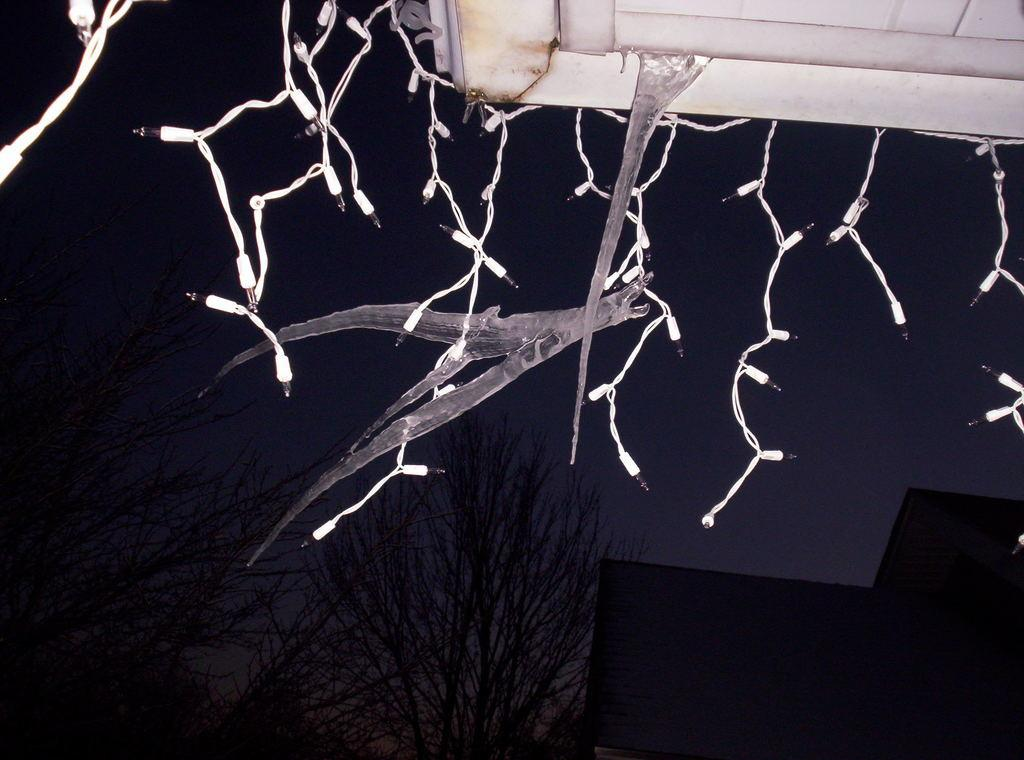What type of lights are in the image? There are white color series lights in the image. Where are the lights located? The lights are placed on the top. What can be seen in the background of the image? There is a group of trees and at least one building in the background of the image. What part of the natural environment is visible in the image? The sky is visible in the background of the image. What type of milk is being produced by the trees in the image? There are no trees producing milk in the image; the trees are part of the natural environment in the background. 